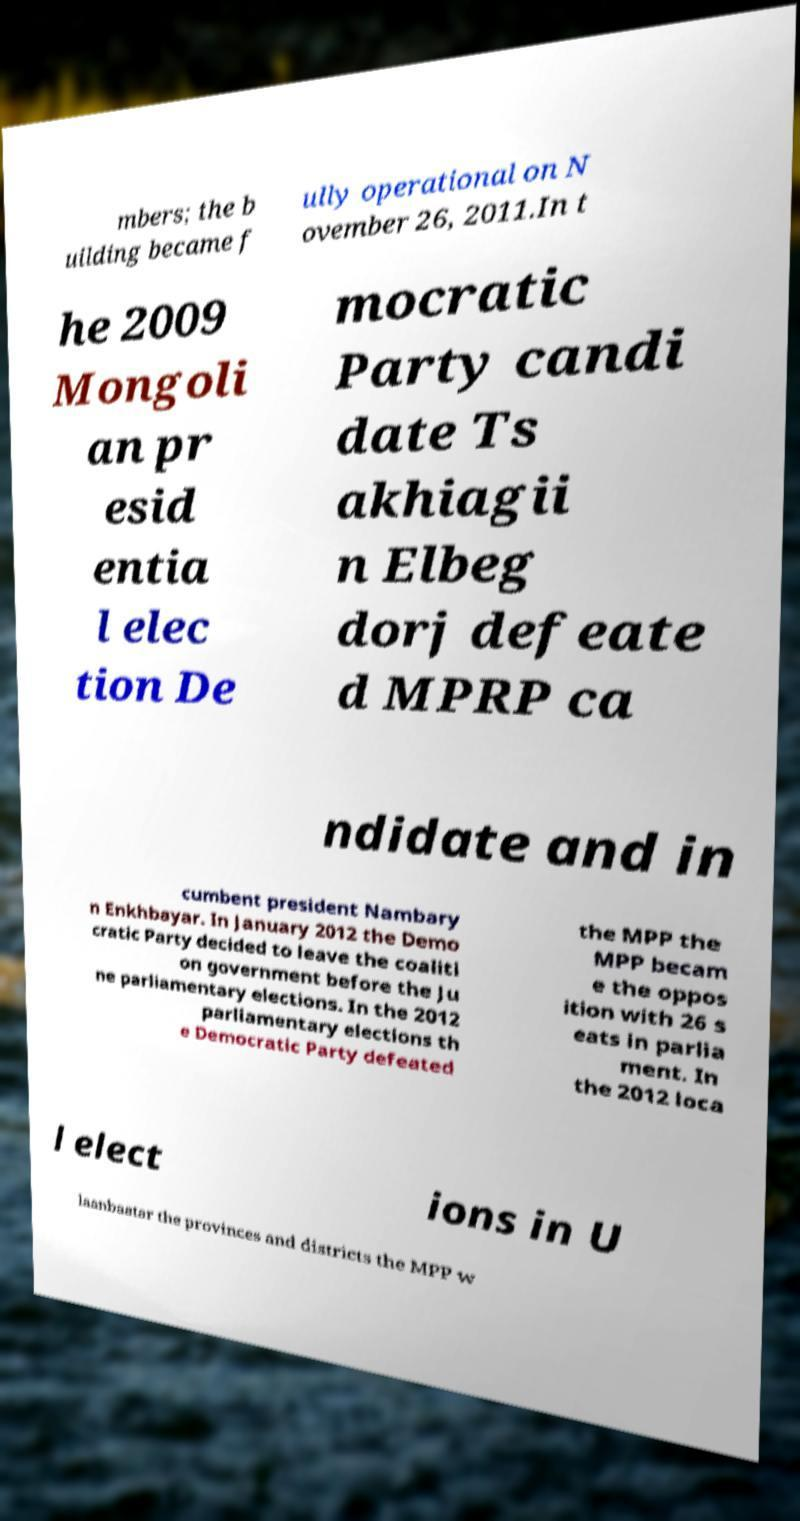I need the written content from this picture converted into text. Can you do that? mbers; the b uilding became f ully operational on N ovember 26, 2011.In t he 2009 Mongoli an pr esid entia l elec tion De mocratic Party candi date Ts akhiagii n Elbeg dorj defeate d MPRP ca ndidate and in cumbent president Nambary n Enkhbayar. In January 2012 the Demo cratic Party decided to leave the coaliti on government before the Ju ne parliamentary elections. In the 2012 parliamentary elections th e Democratic Party defeated the MPP the MPP becam e the oppos ition with 26 s eats in parlia ment. In the 2012 loca l elect ions in U laanbaatar the provinces and districts the MPP w 